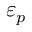Convert formula to latex. <formula><loc_0><loc_0><loc_500><loc_500>\varepsilon _ { p }</formula> 